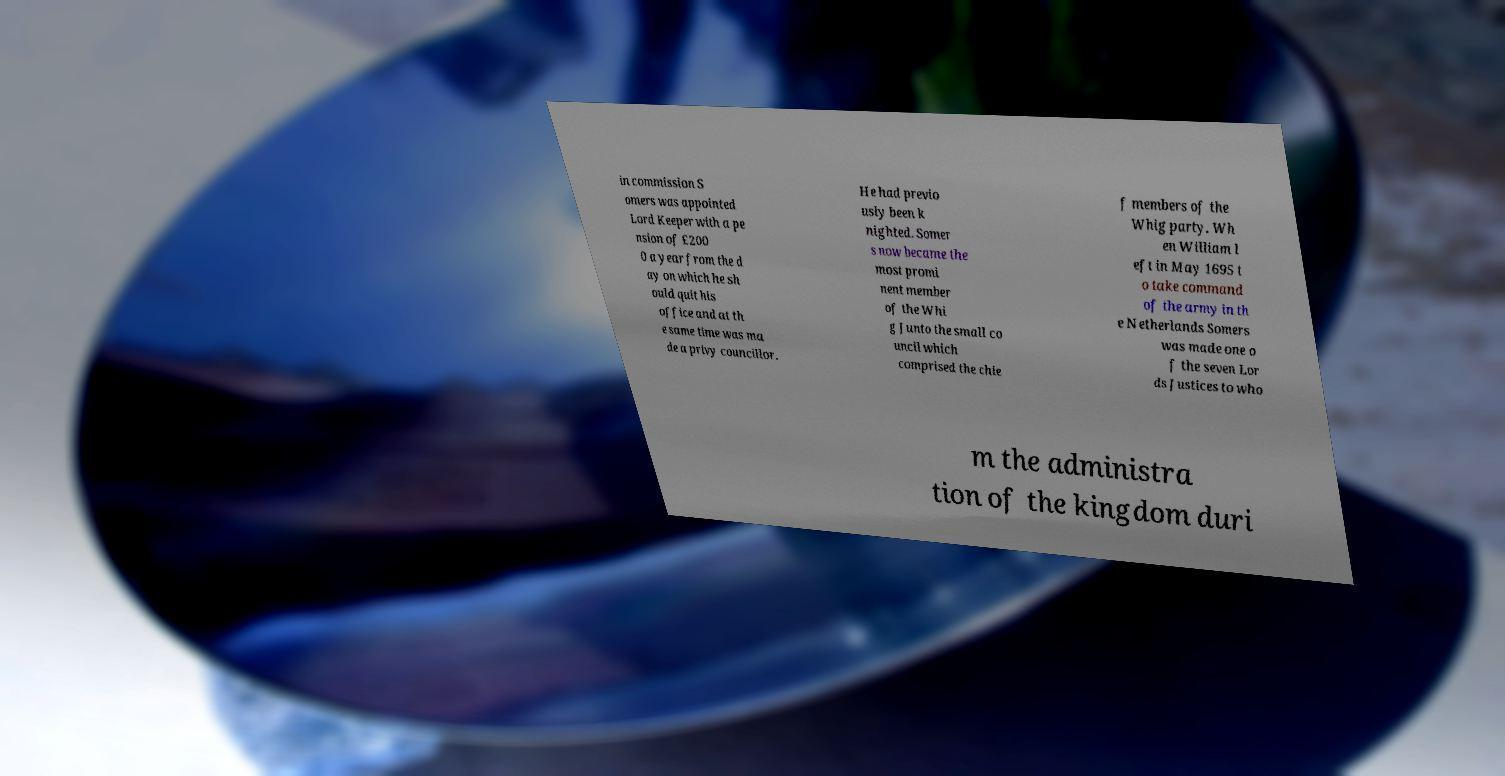There's text embedded in this image that I need extracted. Can you transcribe it verbatim? in commission S omers was appointed Lord Keeper with a pe nsion of £200 0 a year from the d ay on which he sh ould quit his office and at th e same time was ma de a privy councillor. He had previo usly been k nighted. Somer s now became the most promi nent member of the Whi g Junto the small co uncil which comprised the chie f members of the Whig party. Wh en William l eft in May 1695 t o take command of the army in th e Netherlands Somers was made one o f the seven Lor ds Justices to who m the administra tion of the kingdom duri 